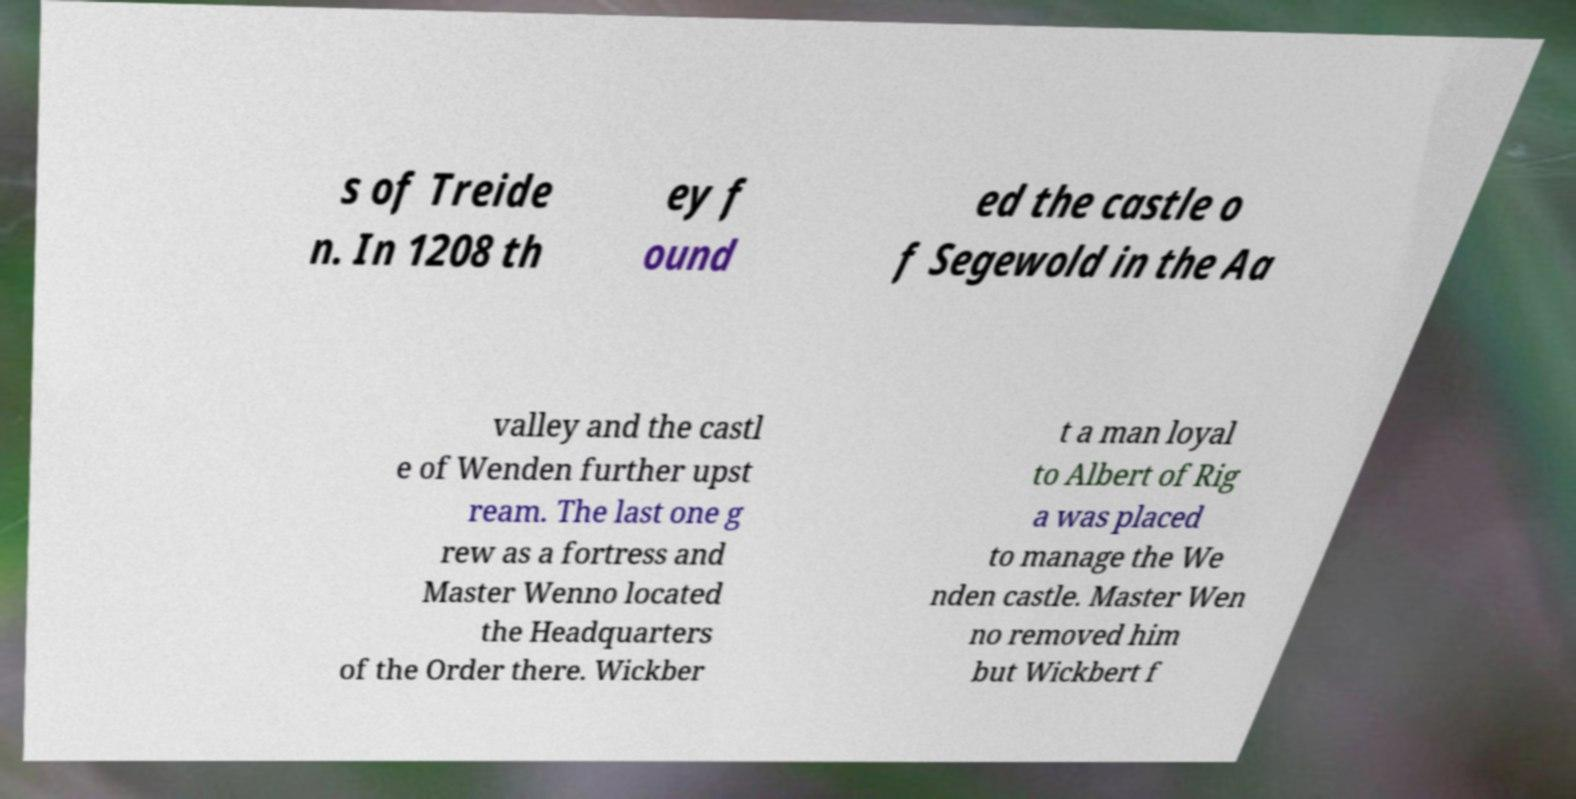Please identify and transcribe the text found in this image. s of Treide n. In 1208 th ey f ound ed the castle o f Segewold in the Aa valley and the castl e of Wenden further upst ream. The last one g rew as a fortress and Master Wenno located the Headquarters of the Order there. Wickber t a man loyal to Albert of Rig a was placed to manage the We nden castle. Master Wen no removed him but Wickbert f 